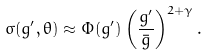<formula> <loc_0><loc_0><loc_500><loc_500>\sigma ( g ^ { \prime } , \theta ) \approx \Phi ( g ^ { \prime } ) \left ( \frac { g ^ { \prime } } { \bar { g } } \right ) ^ { 2 + \gamma } .</formula> 